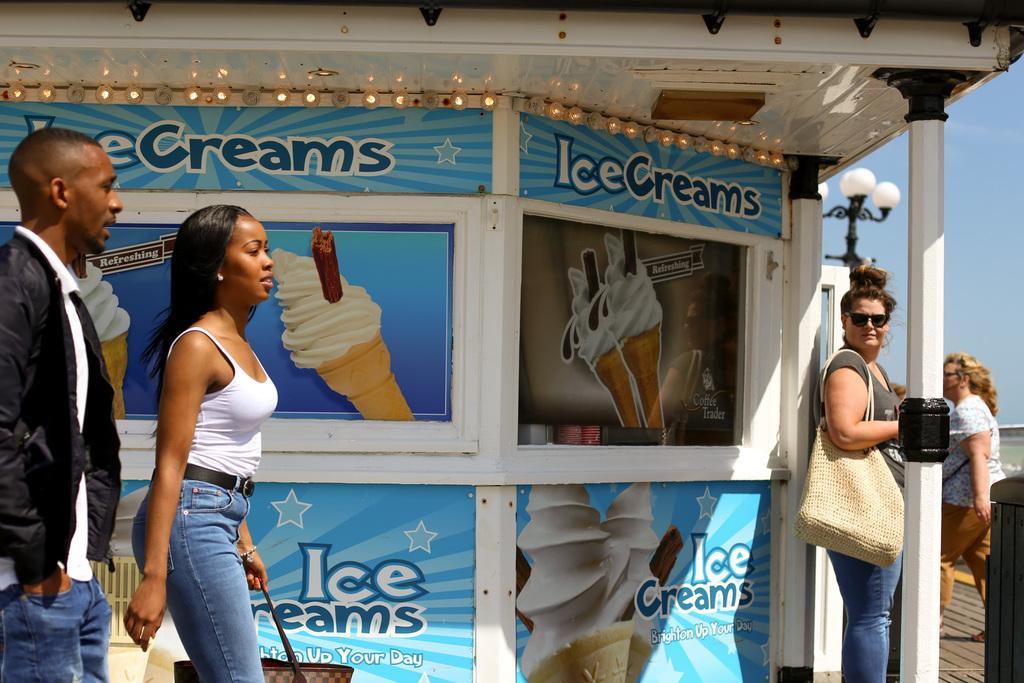In one or two sentences, can you explain what this image depicts? To the left side of the image we can see one man and woman. Man is wearing black color jacket with jeans and woman is wearing white top with jeans and holding brown bag. Right side of the image two women are there. In the middle of the image posters are passed to the wall and one pillar is there. 